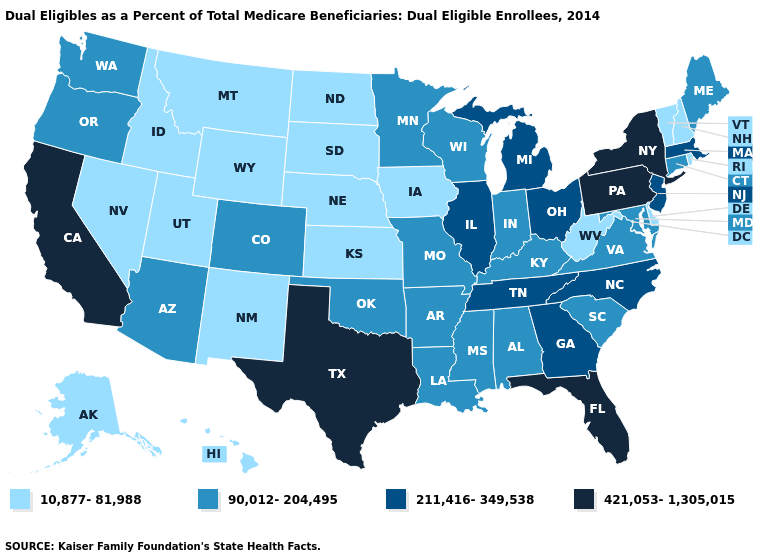Does Wyoming have the lowest value in the USA?
Short answer required. Yes. Name the states that have a value in the range 421,053-1,305,015?
Short answer required. California, Florida, New York, Pennsylvania, Texas. What is the value of Alabama?
Answer briefly. 90,012-204,495. What is the value of North Carolina?
Answer briefly. 211,416-349,538. What is the value of Alabama?
Quick response, please. 90,012-204,495. Does Indiana have the lowest value in the USA?
Be succinct. No. Does the first symbol in the legend represent the smallest category?
Concise answer only. Yes. Is the legend a continuous bar?
Quick response, please. No. Does Hawaii have the lowest value in the USA?
Quick response, please. Yes. What is the lowest value in the USA?
Answer briefly. 10,877-81,988. What is the highest value in states that border South Dakota?
Concise answer only. 90,012-204,495. What is the value of Alabama?
Answer briefly. 90,012-204,495. Does Tennessee have the lowest value in the South?
Give a very brief answer. No. Which states have the lowest value in the West?
Quick response, please. Alaska, Hawaii, Idaho, Montana, Nevada, New Mexico, Utah, Wyoming. Is the legend a continuous bar?
Keep it brief. No. 